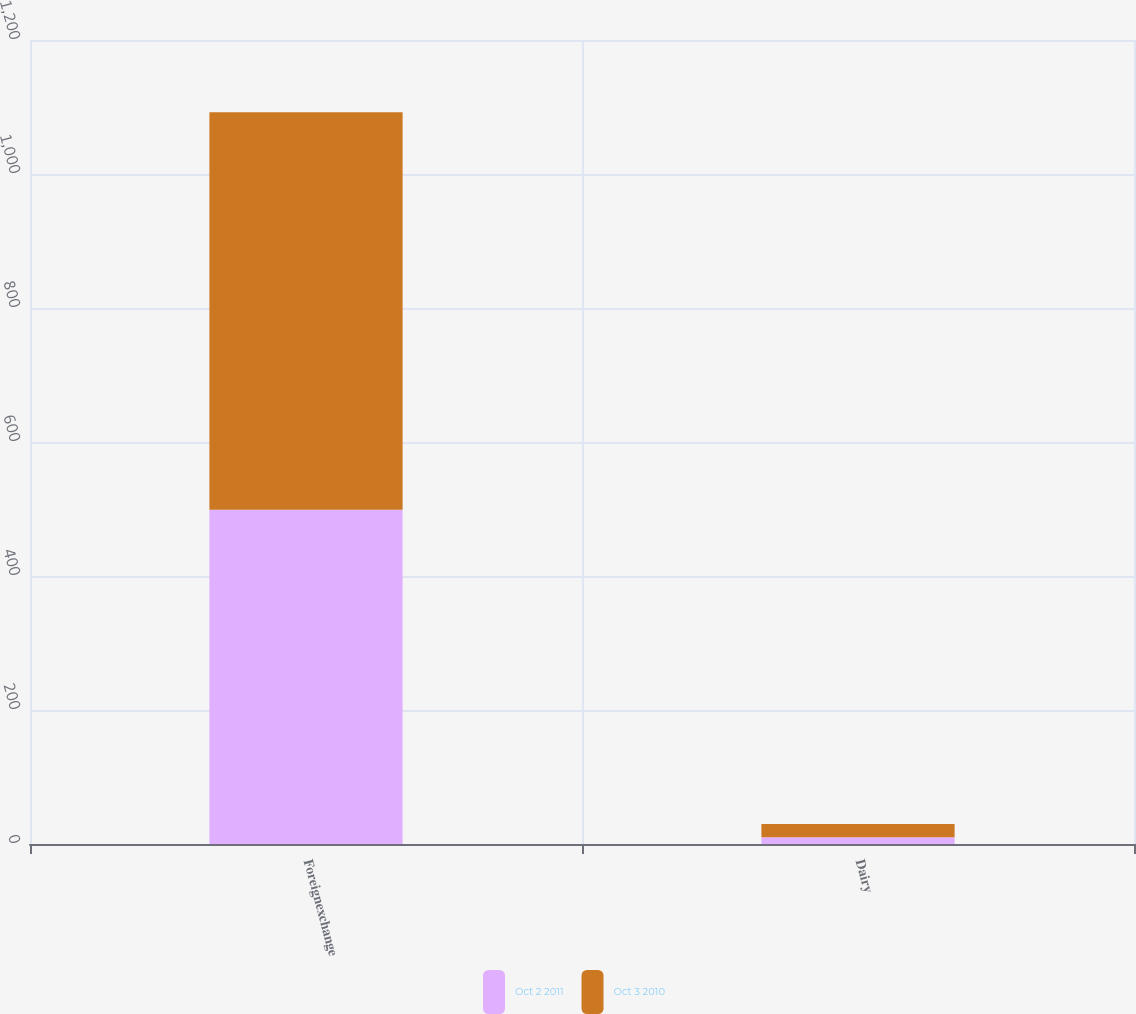<chart> <loc_0><loc_0><loc_500><loc_500><stacked_bar_chart><ecel><fcel>Foreignexchange<fcel>Dairy<nl><fcel>Oct 2 2011<fcel>499<fcel>10<nl><fcel>Oct 3 2010<fcel>593<fcel>20<nl></chart> 